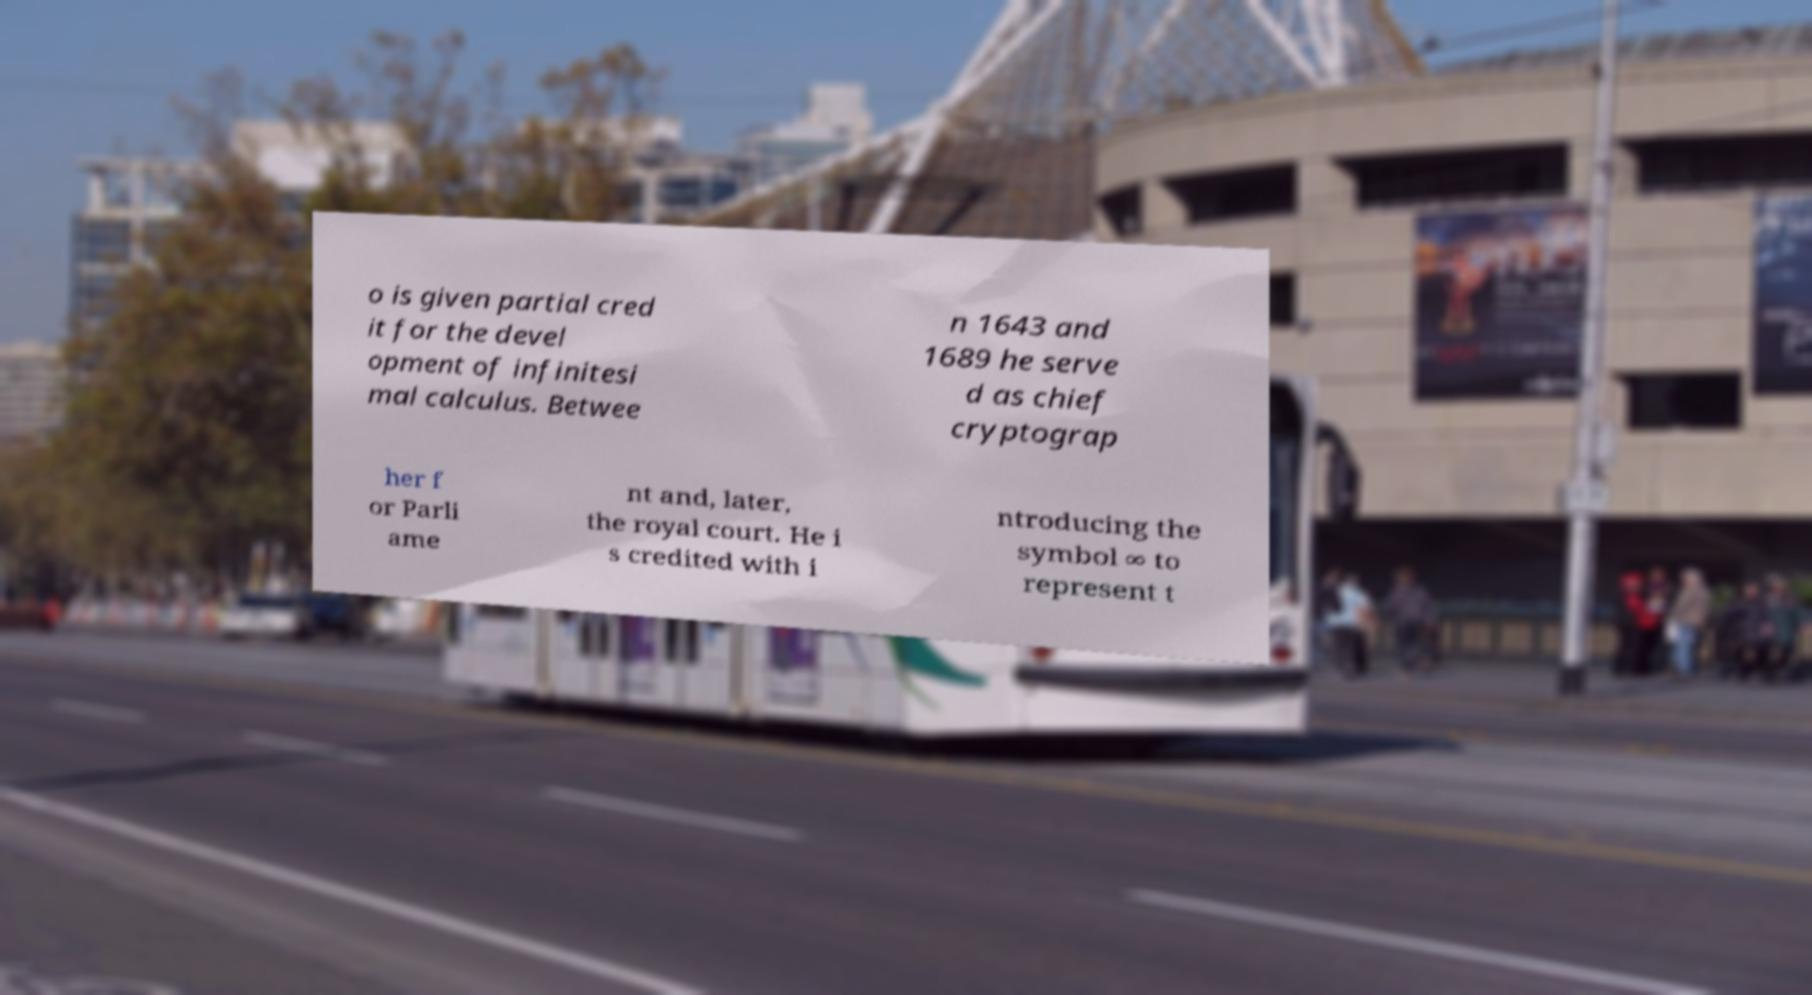I need the written content from this picture converted into text. Can you do that? o is given partial cred it for the devel opment of infinitesi mal calculus. Betwee n 1643 and 1689 he serve d as chief cryptograp her f or Parli ame nt and, later, the royal court. He i s credited with i ntroducing the symbol ∞ to represent t 